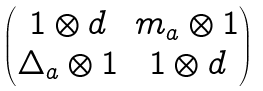Convert formula to latex. <formula><loc_0><loc_0><loc_500><loc_500>\begin{pmatrix} 1 \otimes d & m _ { a } \otimes 1 \\ \Delta _ { a } \otimes 1 & 1 \otimes d \end{pmatrix}</formula> 